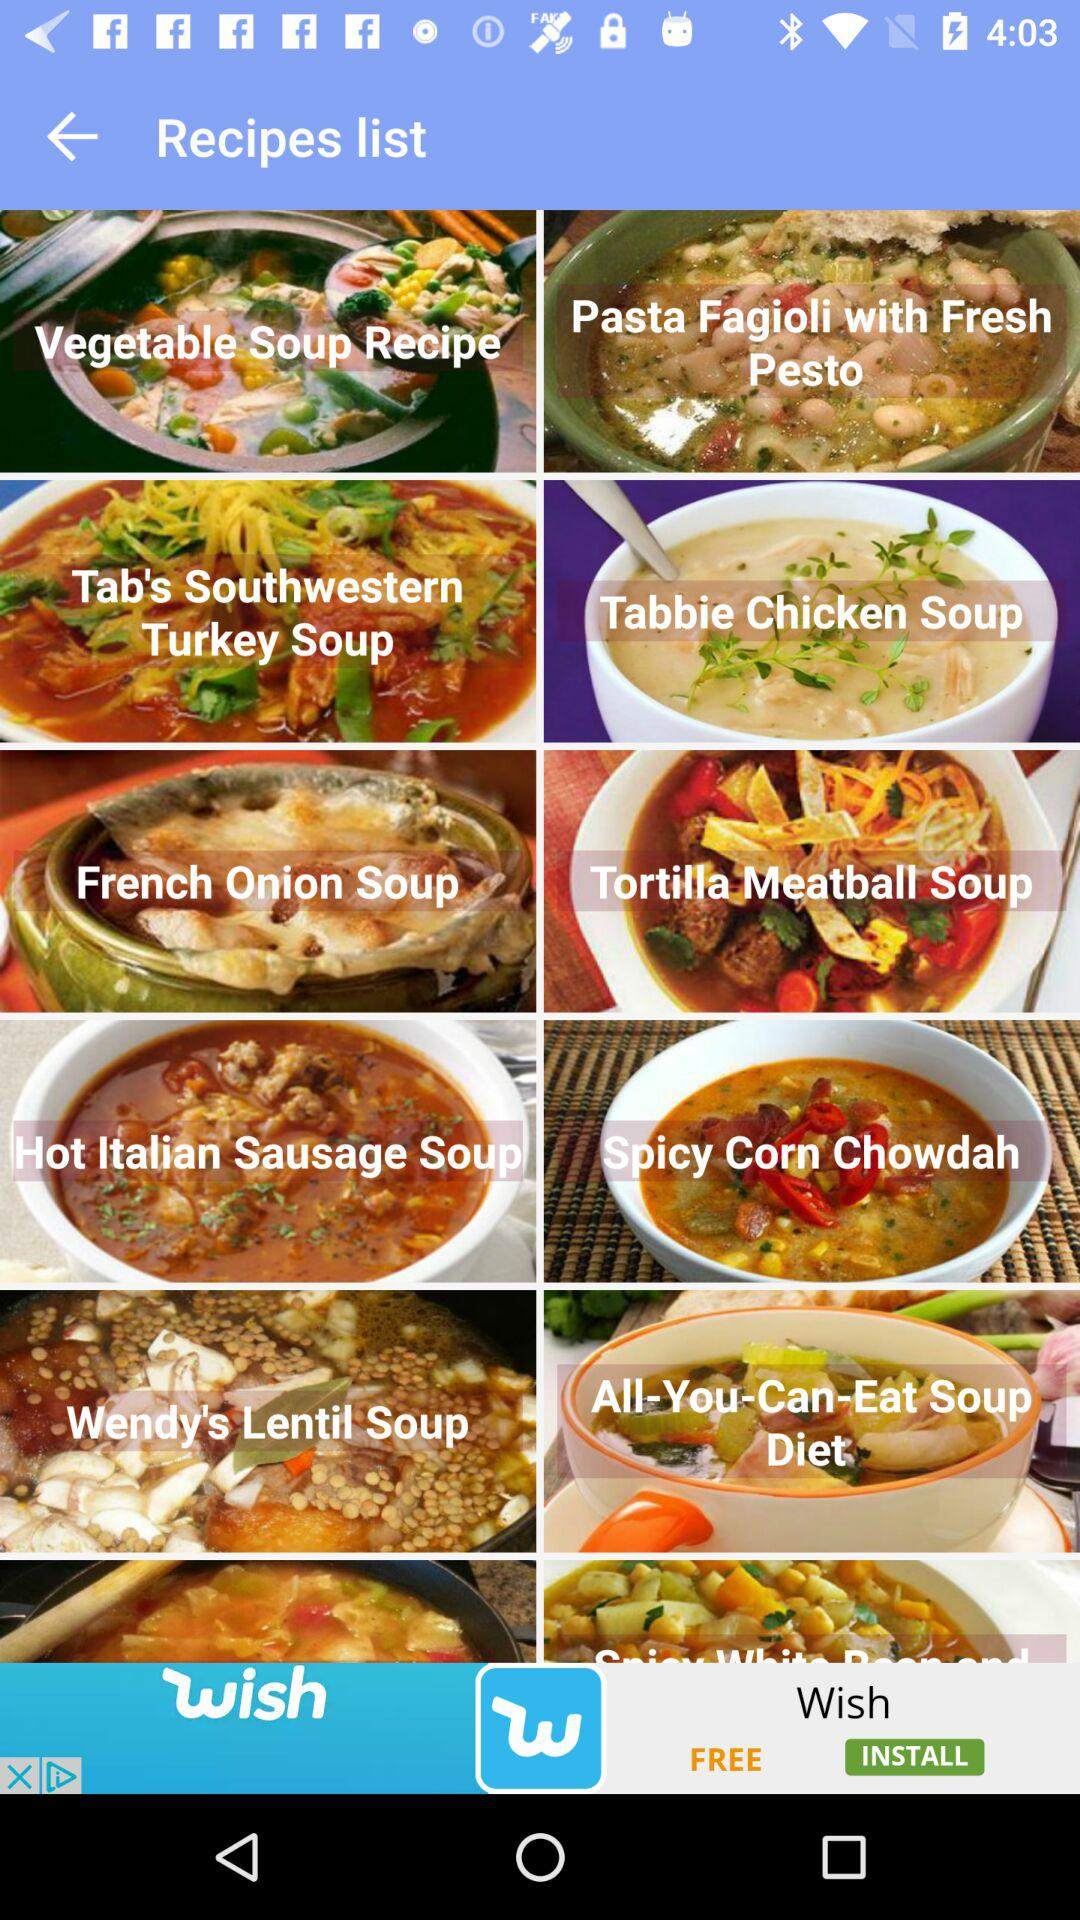Which recipe has the longest name?
Answer the question using a single word or phrase. All-You-Can-Eat Soup Diet 